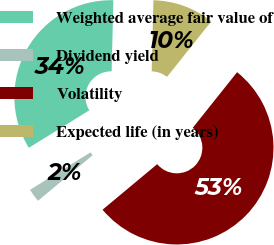<chart> <loc_0><loc_0><loc_500><loc_500><pie_chart><fcel>Weighted average fair value of<fcel>Dividend yield<fcel>Volatility<fcel>Expected life (in years)<nl><fcel>34.22%<fcel>2.23%<fcel>53.23%<fcel>10.33%<nl></chart> 